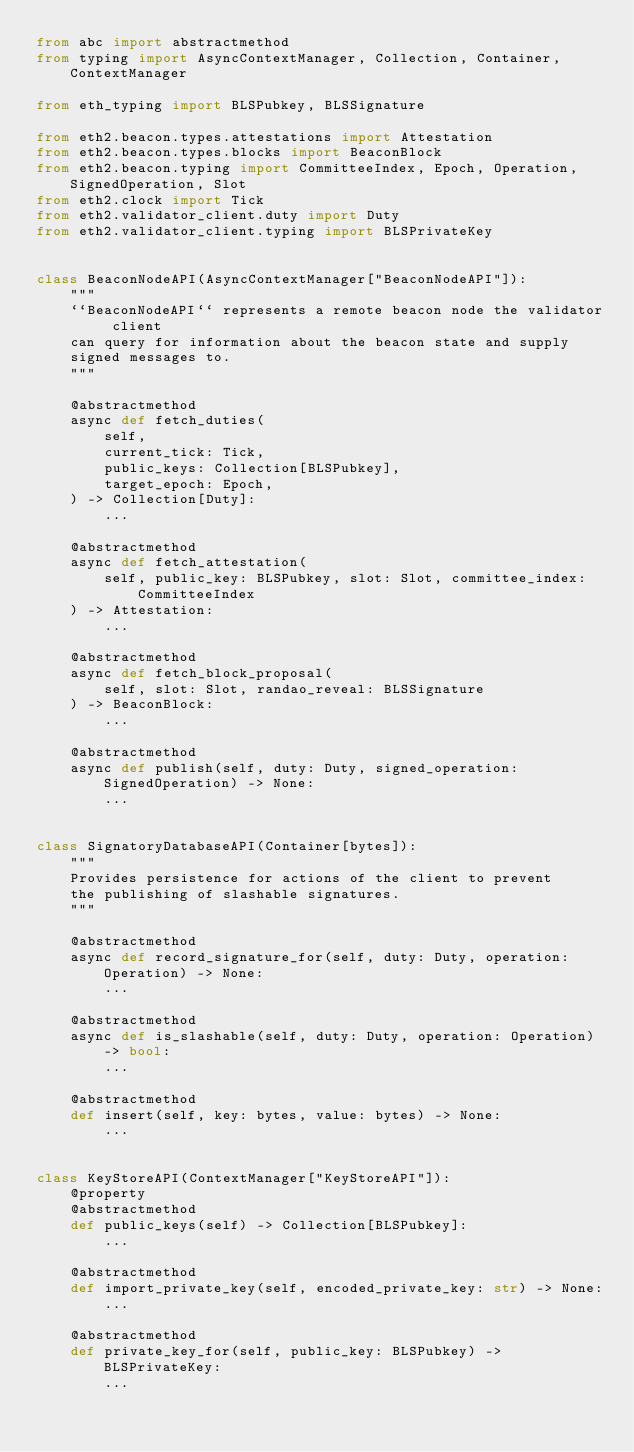<code> <loc_0><loc_0><loc_500><loc_500><_Python_>from abc import abstractmethod
from typing import AsyncContextManager, Collection, Container, ContextManager

from eth_typing import BLSPubkey, BLSSignature

from eth2.beacon.types.attestations import Attestation
from eth2.beacon.types.blocks import BeaconBlock
from eth2.beacon.typing import CommitteeIndex, Epoch, Operation, SignedOperation, Slot
from eth2.clock import Tick
from eth2.validator_client.duty import Duty
from eth2.validator_client.typing import BLSPrivateKey


class BeaconNodeAPI(AsyncContextManager["BeaconNodeAPI"]):
    """
    ``BeaconNodeAPI`` represents a remote beacon node the validator client
    can query for information about the beacon state and supply
    signed messages to.
    """

    @abstractmethod
    async def fetch_duties(
        self,
        current_tick: Tick,
        public_keys: Collection[BLSPubkey],
        target_epoch: Epoch,
    ) -> Collection[Duty]:
        ...

    @abstractmethod
    async def fetch_attestation(
        self, public_key: BLSPubkey, slot: Slot, committee_index: CommitteeIndex
    ) -> Attestation:
        ...

    @abstractmethod
    async def fetch_block_proposal(
        self, slot: Slot, randao_reveal: BLSSignature
    ) -> BeaconBlock:
        ...

    @abstractmethod
    async def publish(self, duty: Duty, signed_operation: SignedOperation) -> None:
        ...


class SignatoryDatabaseAPI(Container[bytes]):
    """
    Provides persistence for actions of the client to prevent
    the publishing of slashable signatures.
    """

    @abstractmethod
    async def record_signature_for(self, duty: Duty, operation: Operation) -> None:
        ...

    @abstractmethod
    async def is_slashable(self, duty: Duty, operation: Operation) -> bool:
        ...

    @abstractmethod
    def insert(self, key: bytes, value: bytes) -> None:
        ...


class KeyStoreAPI(ContextManager["KeyStoreAPI"]):
    @property
    @abstractmethod
    def public_keys(self) -> Collection[BLSPubkey]:
        ...

    @abstractmethod
    def import_private_key(self, encoded_private_key: str) -> None:
        ...

    @abstractmethod
    def private_key_for(self, public_key: BLSPubkey) -> BLSPrivateKey:
        ...
</code> 